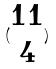Convert formula to latex. <formula><loc_0><loc_0><loc_500><loc_500>( \begin{matrix} 1 1 \\ 4 \end{matrix} )</formula> 